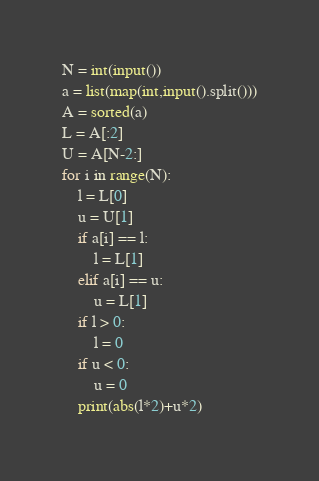Convert code to text. <code><loc_0><loc_0><loc_500><loc_500><_Python_>N = int(input())
a = list(map(int,input().split()))
A = sorted(a)
L = A[:2]
U = A[N-2:]
for i in range(N):
    l = L[0]
    u = U[1]
    if a[i] == l:
        l = L[1]
    elif a[i] == u:
        u = L[1]
    if l > 0:
        l = 0
    if u < 0:
        u = 0
    print(abs(l*2)+u*2)</code> 